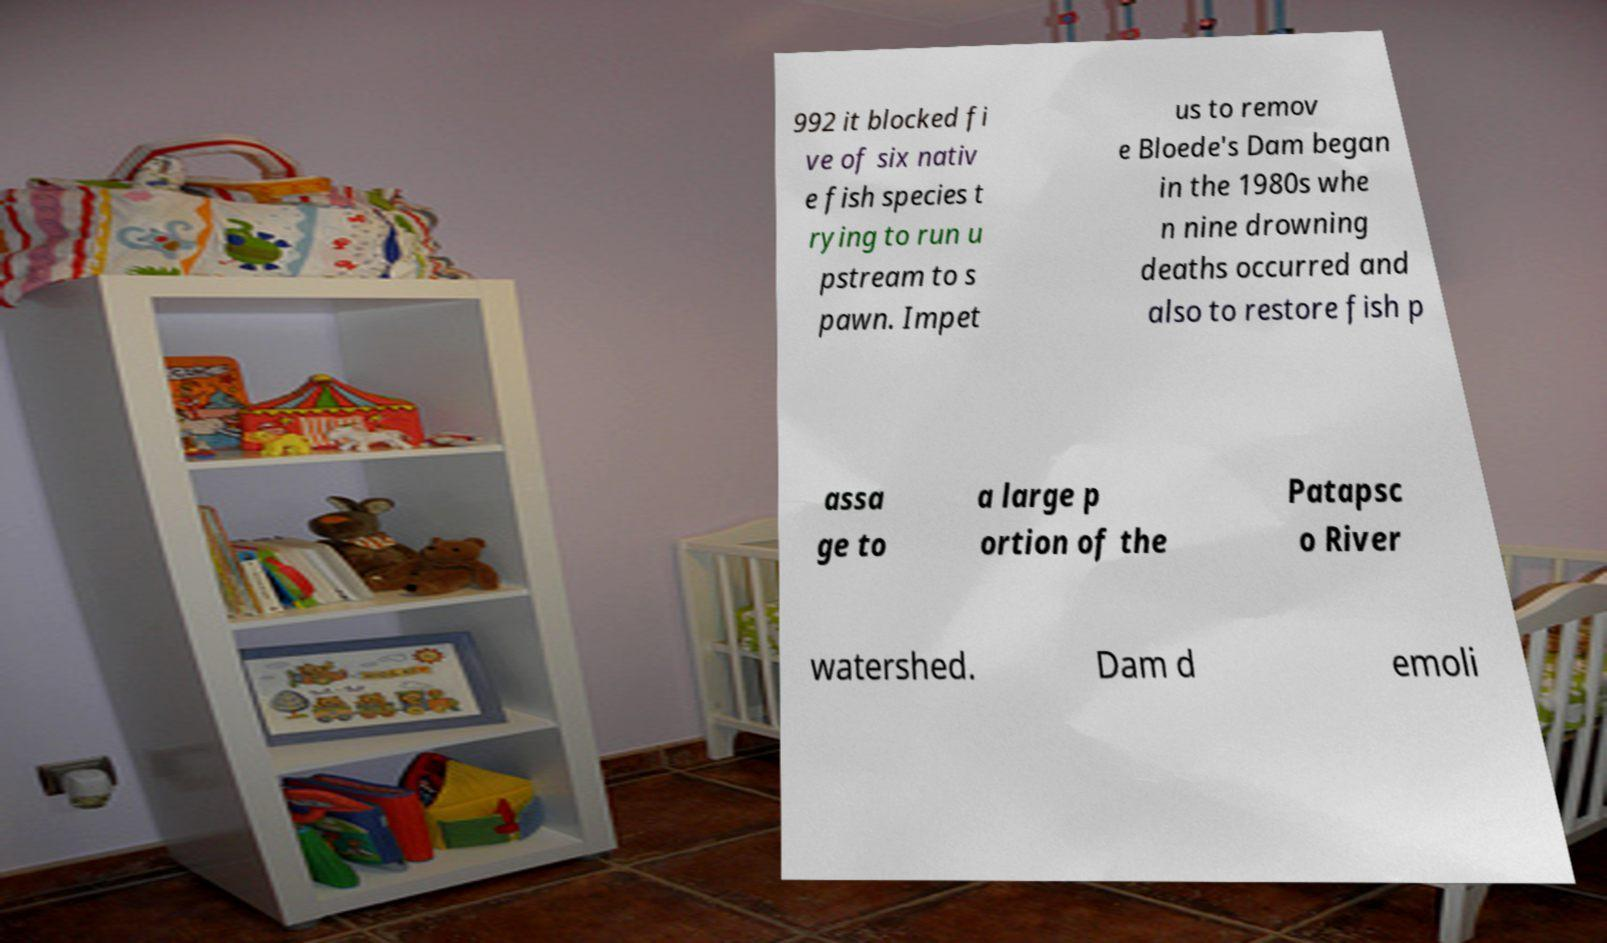Could you extract and type out the text from this image? 992 it blocked fi ve of six nativ e fish species t rying to run u pstream to s pawn. Impet us to remov e Bloede's Dam began in the 1980s whe n nine drowning deaths occurred and also to restore fish p assa ge to a large p ortion of the Patapsc o River watershed. Dam d emoli 